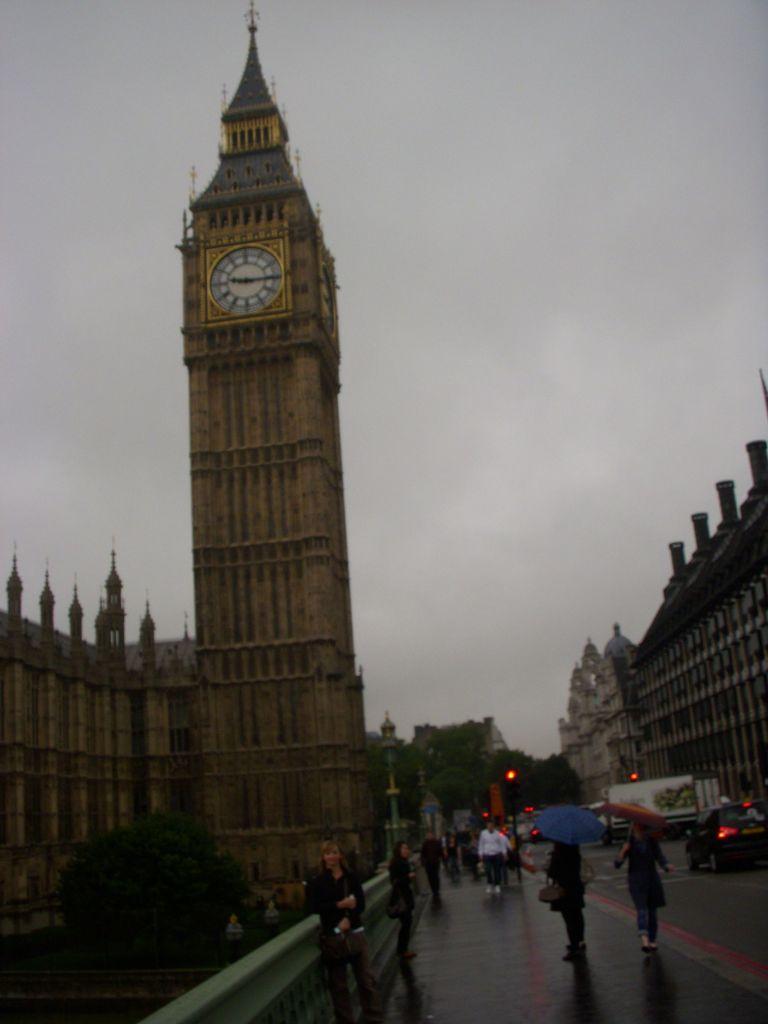How would you summarize this image in a sentence or two? At the bottom of the image there is a road with few people are standing and holding umbrellas in their hands. On the road there are vehicles and also there are poles with traffic signals. And also there is a fencing wall. And in the image there are trees. And also there are many buildings with walls and pillars. There is a pillar with clock. At the top of the image there is sky. 